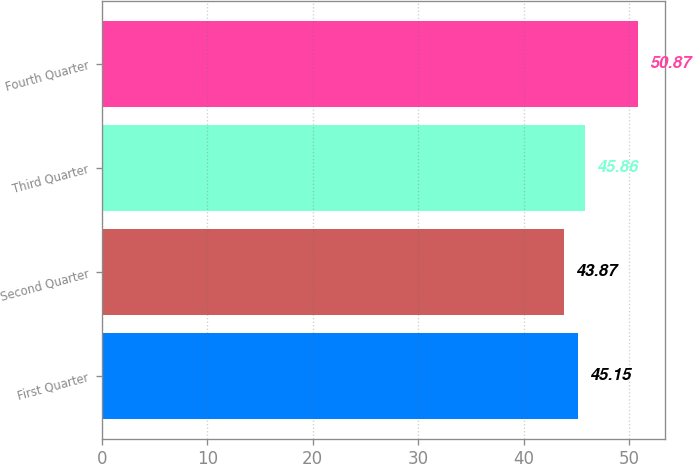<chart> <loc_0><loc_0><loc_500><loc_500><bar_chart><fcel>First Quarter<fcel>Second Quarter<fcel>Third Quarter<fcel>Fourth Quarter<nl><fcel>45.15<fcel>43.87<fcel>45.86<fcel>50.87<nl></chart> 